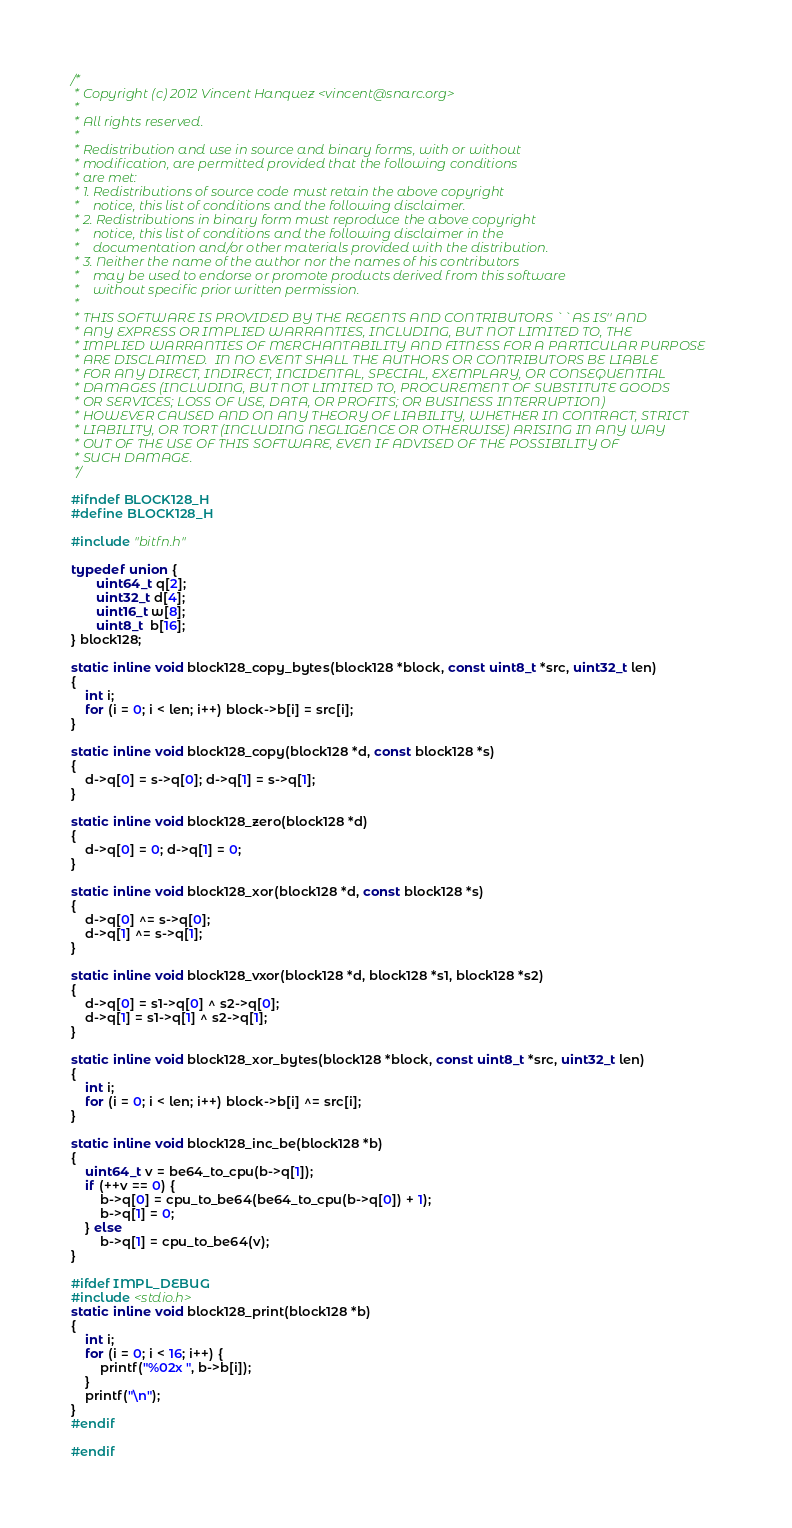Convert code to text. <code><loc_0><loc_0><loc_500><loc_500><_C_>/*
 * Copyright (c) 2012 Vincent Hanquez <vincent@snarc.org>
 * 
 * All rights reserved.
 * 
 * Redistribution and use in source and binary forms, with or without
 * modification, are permitted provided that the following conditions
 * are met:
 * 1. Redistributions of source code must retain the above copyright
 *    notice, this list of conditions and the following disclaimer.
 * 2. Redistributions in binary form must reproduce the above copyright
 *    notice, this list of conditions and the following disclaimer in the
 *    documentation and/or other materials provided with the distribution.
 * 3. Neither the name of the author nor the names of his contributors
 *    may be used to endorse or promote products derived from this software
 *    without specific prior written permission.
 * 
 * THIS SOFTWARE IS PROVIDED BY THE REGENTS AND CONTRIBUTORS ``AS IS'' AND
 * ANY EXPRESS OR IMPLIED WARRANTIES, INCLUDING, BUT NOT LIMITED TO, THE
 * IMPLIED WARRANTIES OF MERCHANTABILITY AND FITNESS FOR A PARTICULAR PURPOSE
 * ARE DISCLAIMED.  IN NO EVENT SHALL THE AUTHORS OR CONTRIBUTORS BE LIABLE
 * FOR ANY DIRECT, INDIRECT, INCIDENTAL, SPECIAL, EXEMPLARY, OR CONSEQUENTIAL
 * DAMAGES (INCLUDING, BUT NOT LIMITED TO, PROCUREMENT OF SUBSTITUTE GOODS
 * OR SERVICES; LOSS OF USE, DATA, OR PROFITS; OR BUSINESS INTERRUPTION)
 * HOWEVER CAUSED AND ON ANY THEORY OF LIABILITY, WHETHER IN CONTRACT, STRICT
 * LIABILITY, OR TORT (INCLUDING NEGLIGENCE OR OTHERWISE) ARISING IN ANY WAY
 * OUT OF THE USE OF THIS SOFTWARE, EVEN IF ADVISED OF THE POSSIBILITY OF
 * SUCH DAMAGE.
 */

#ifndef BLOCK128_H
#define BLOCK128_H

#include "bitfn.h"

typedef union {
       uint64_t q[2];
       uint32_t d[4];
       uint16_t w[8];
       uint8_t  b[16];
} block128;

static inline void block128_copy_bytes(block128 *block, const uint8_t *src, uint32_t len)
{
	int i;
	for (i = 0; i < len; i++) block->b[i] = src[i];
}

static inline void block128_copy(block128 *d, const block128 *s)
{
	d->q[0] = s->q[0]; d->q[1] = s->q[1];
}

static inline void block128_zero(block128 *d)
{
	d->q[0] = 0; d->q[1] = 0;
}

static inline void block128_xor(block128 *d, const block128 *s)
{
	d->q[0] ^= s->q[0];
	d->q[1] ^= s->q[1];
}

static inline void block128_vxor(block128 *d, block128 *s1, block128 *s2)
{
	d->q[0] = s1->q[0] ^ s2->q[0];
	d->q[1] = s1->q[1] ^ s2->q[1];
}

static inline void block128_xor_bytes(block128 *block, const uint8_t *src, uint32_t len)
{
	int i;
	for (i = 0; i < len; i++) block->b[i] ^= src[i];
}

static inline void block128_inc_be(block128 *b)
{
	uint64_t v = be64_to_cpu(b->q[1]);
	if (++v == 0) {
		b->q[0] = cpu_to_be64(be64_to_cpu(b->q[0]) + 1);
		b->q[1] = 0;
	} else
		b->q[1] = cpu_to_be64(v);
}

#ifdef IMPL_DEBUG
#include <stdio.h>
static inline void block128_print(block128 *b)
{
	int i;
	for (i = 0; i < 16; i++) {
		printf("%02x ", b->b[i]);
	}
	printf("\n");
}
#endif

#endif
</code> 